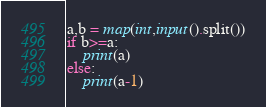<code> <loc_0><loc_0><loc_500><loc_500><_Python_>a,b = map(int,input().split())
if b>=a:
    print(a)
else:
    print(a-1)</code> 